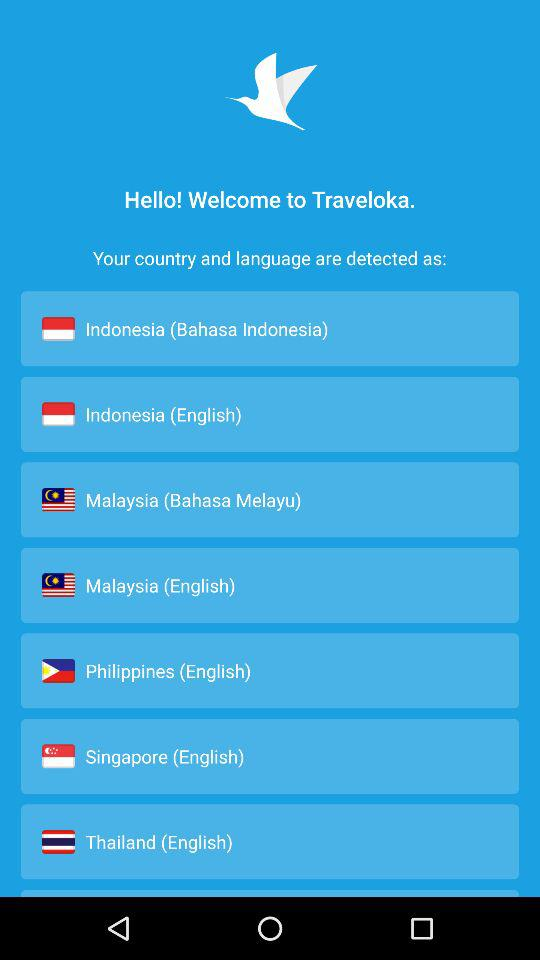What is the application name? The application name is "Traveloka". 